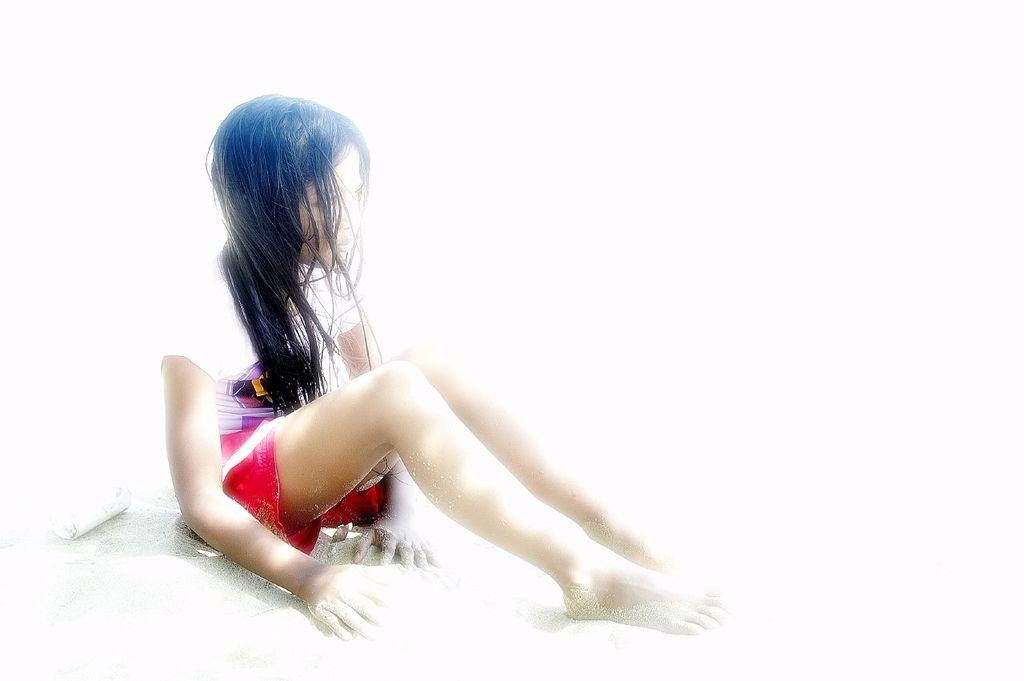Who is present in the image? There is a woman in the image. What is the woman doing in the image? The woman is seated on the sand. What type of plant is growing on the woman's feet in the image? There is no plant growing on the woman's feet in the image, as she is seated on the sand and her feet are not visible. 